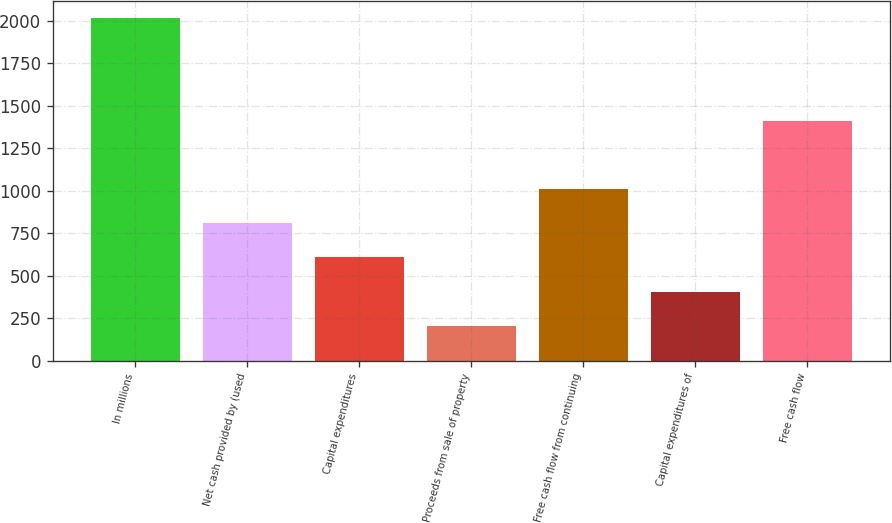Convert chart to OTSL. <chart><loc_0><loc_0><loc_500><loc_500><bar_chart><fcel>In millions<fcel>Net cash provided by (used<fcel>Capital expenditures<fcel>Proceeds from sale of property<fcel>Free cash flow from continuing<fcel>Capital expenditures of<fcel>Free cash flow<nl><fcel>2015<fcel>808.76<fcel>607.72<fcel>205.64<fcel>1009.8<fcel>406.68<fcel>1411.88<nl></chart> 